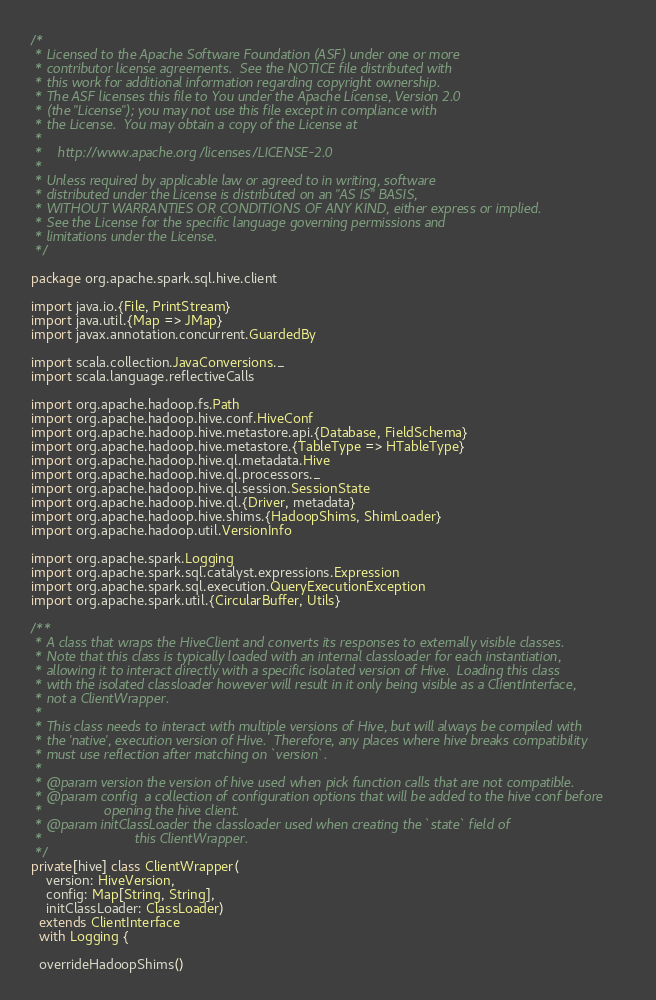Convert code to text. <code><loc_0><loc_0><loc_500><loc_500><_Scala_>/*
 * Licensed to the Apache Software Foundation (ASF) under one or more
 * contributor license agreements.  See the NOTICE file distributed with
 * this work for additional information regarding copyright ownership.
 * The ASF licenses this file to You under the Apache License, Version 2.0
 * (the "License"); you may not use this file except in compliance with
 * the License.  You may obtain a copy of the License at
 *
 *    http://www.apache.org/licenses/LICENSE-2.0
 *
 * Unless required by applicable law or agreed to in writing, software
 * distributed under the License is distributed on an "AS IS" BASIS,
 * WITHOUT WARRANTIES OR CONDITIONS OF ANY KIND, either express or implied.
 * See the License for the specific language governing permissions and
 * limitations under the License.
 */

package org.apache.spark.sql.hive.client

import java.io.{File, PrintStream}
import java.util.{Map => JMap}
import javax.annotation.concurrent.GuardedBy

import scala.collection.JavaConversions._
import scala.language.reflectiveCalls

import org.apache.hadoop.fs.Path
import org.apache.hadoop.hive.conf.HiveConf
import org.apache.hadoop.hive.metastore.api.{Database, FieldSchema}
import org.apache.hadoop.hive.metastore.{TableType => HTableType}
import org.apache.hadoop.hive.ql.metadata.Hive
import org.apache.hadoop.hive.ql.processors._
import org.apache.hadoop.hive.ql.session.SessionState
import org.apache.hadoop.hive.ql.{Driver, metadata}
import org.apache.hadoop.hive.shims.{HadoopShims, ShimLoader}
import org.apache.hadoop.util.VersionInfo

import org.apache.spark.Logging
import org.apache.spark.sql.catalyst.expressions.Expression
import org.apache.spark.sql.execution.QueryExecutionException
import org.apache.spark.util.{CircularBuffer, Utils}

/**
 * A class that wraps the HiveClient and converts its responses to externally visible classes.
 * Note that this class is typically loaded with an internal classloader for each instantiation,
 * allowing it to interact directly with a specific isolated version of Hive.  Loading this class
 * with the isolated classloader however will result in it only being visible as a ClientInterface,
 * not a ClientWrapper.
 *
 * This class needs to interact with multiple versions of Hive, but will always be compiled with
 * the 'native', execution version of Hive.  Therefore, any places where hive breaks compatibility
 * must use reflection after matching on `version`.
 *
 * @param version the version of hive used when pick function calls that are not compatible.
 * @param config  a collection of configuration options that will be added to the hive conf before
 *                opening the hive client.
 * @param initClassLoader the classloader used when creating the `state` field of
 *                        this ClientWrapper.
 */
private[hive] class ClientWrapper(
    version: HiveVersion,
    config: Map[String, String],
    initClassLoader: ClassLoader)
  extends ClientInterface
  with Logging {

  overrideHadoopShims()
</code> 